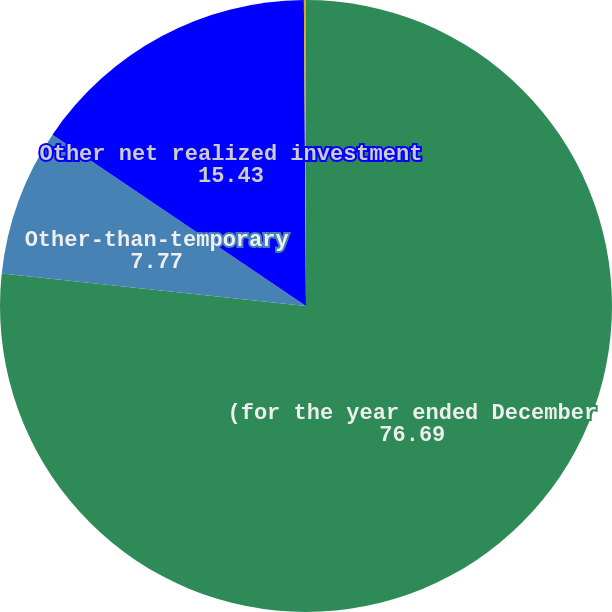<chart> <loc_0><loc_0><loc_500><loc_500><pie_chart><fcel>(for the year ended December<fcel>Other-than-temporary<fcel>Other net realized investment<fcel>Net realized investment gains<nl><fcel>76.69%<fcel>7.77%<fcel>15.43%<fcel>0.11%<nl></chart> 